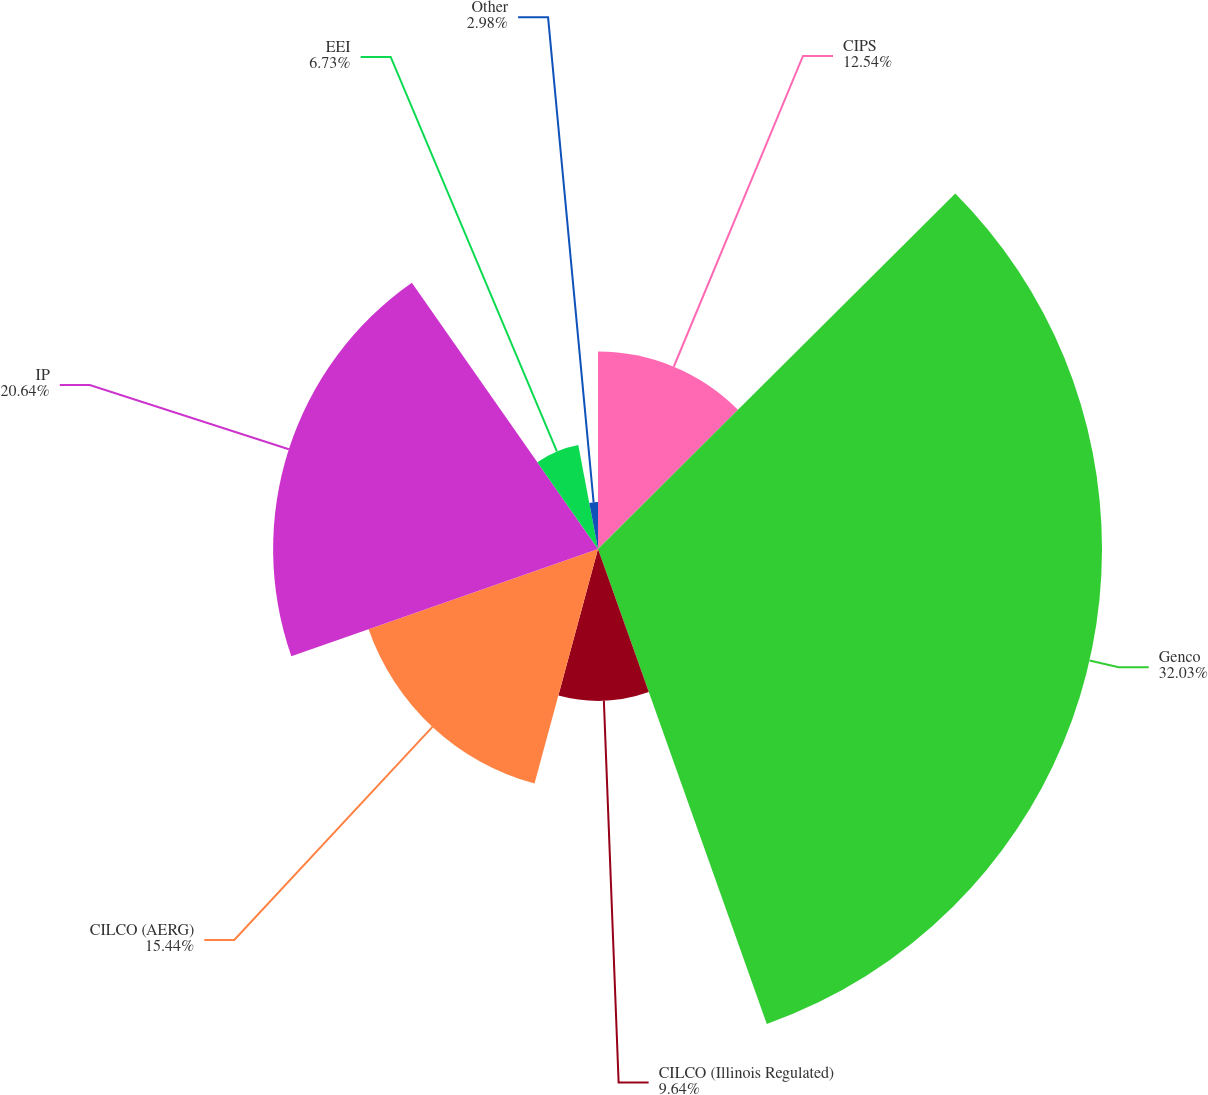Convert chart. <chart><loc_0><loc_0><loc_500><loc_500><pie_chart><fcel>CIPS<fcel>Genco<fcel>CILCO (Illinois Regulated)<fcel>CILCO (AERG)<fcel>IP<fcel>EEI<fcel>Other<nl><fcel>12.54%<fcel>32.02%<fcel>9.64%<fcel>15.44%<fcel>20.64%<fcel>6.73%<fcel>2.98%<nl></chart> 